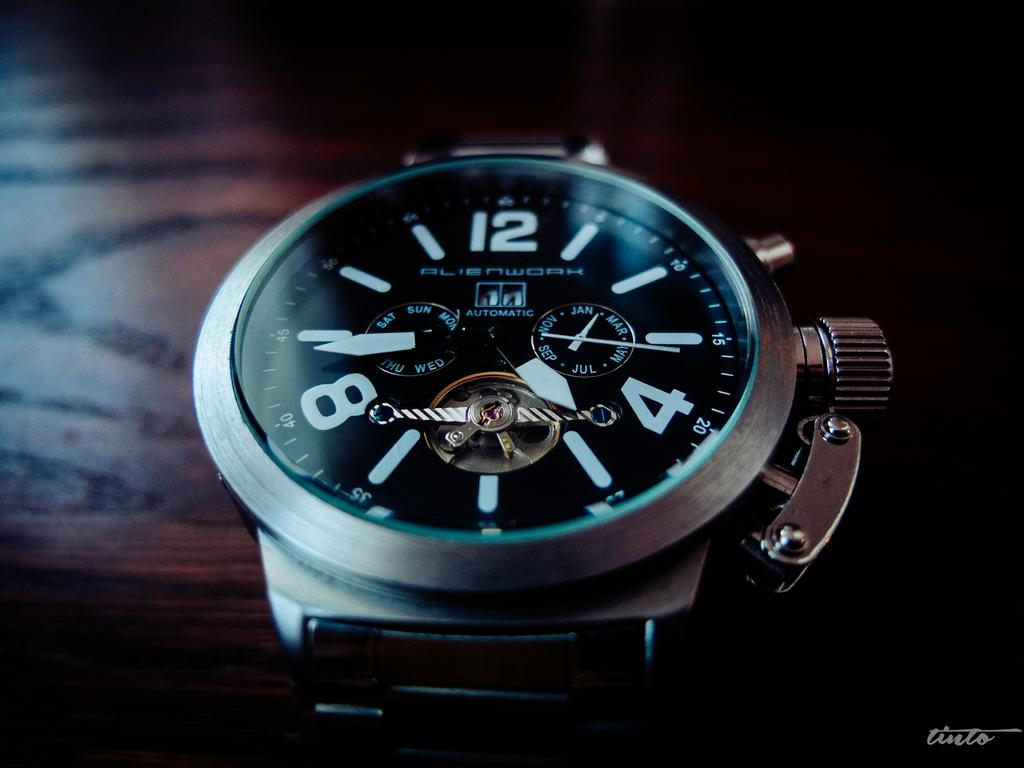<image>
Relay a brief, clear account of the picture shown. A watch with a black dial and the word Alienwork written on it. 